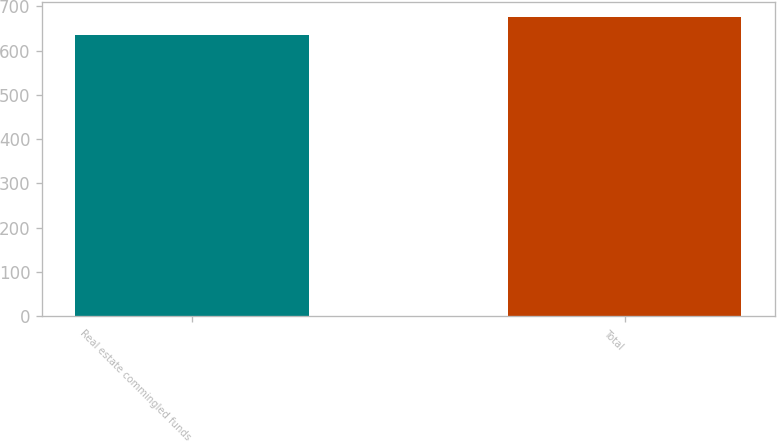<chart> <loc_0><loc_0><loc_500><loc_500><bar_chart><fcel>Real estate commingled funds<fcel>Total<nl><fcel>635<fcel>675<nl></chart> 